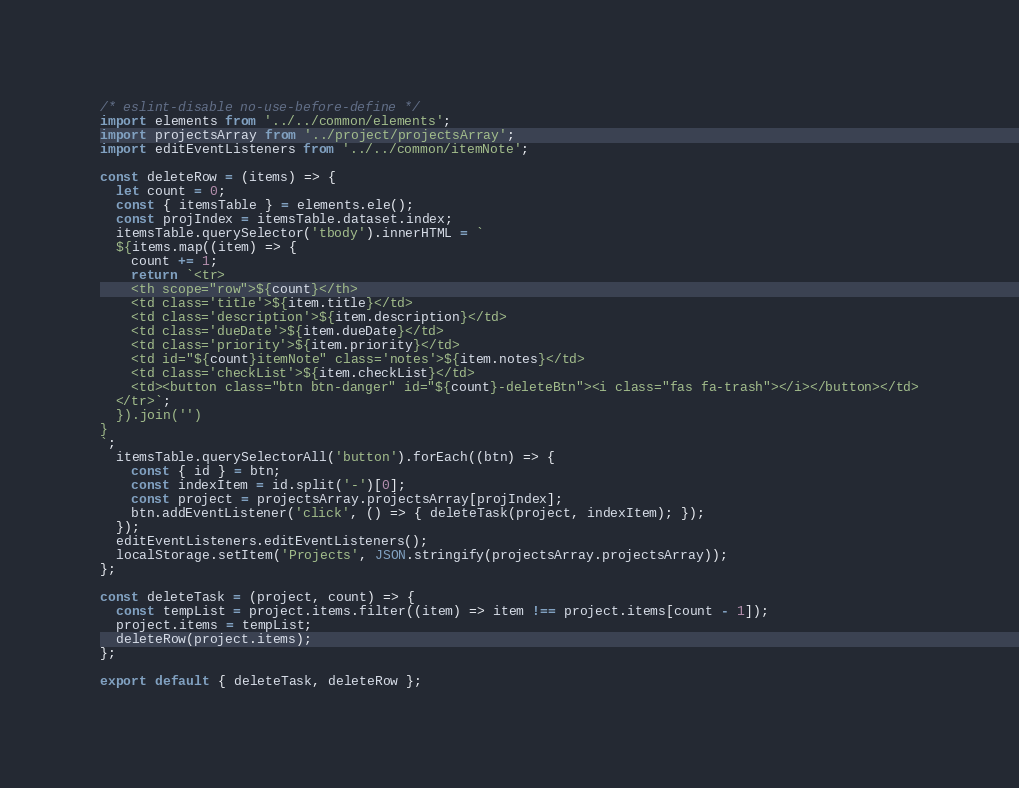Convert code to text. <code><loc_0><loc_0><loc_500><loc_500><_JavaScript_>/* eslint-disable no-use-before-define */
import elements from '../../common/elements';
import projectsArray from '../project/projectsArray';
import editEventListeners from '../../common/itemNote';

const deleteRow = (items) => {
  let count = 0;
  const { itemsTable } = elements.ele();
  const projIndex = itemsTable.dataset.index;
  itemsTable.querySelector('tbody').innerHTML = `
  ${items.map((item) => {
    count += 1;
    return `<tr>
    <th scope="row">${count}</th>
    <td class='title'>${item.title}</td>
    <td class='description'>${item.description}</td>
    <td class='dueDate'>${item.dueDate}</td>
    <td class='priority'>${item.priority}</td>
    <td id="${count}itemNote" class='notes'>${item.notes}</td>
    <td class='checkList'>${item.checkList}</td>
    <td><button class="btn btn-danger" id="${count}-deleteBtn"><i class="fas fa-trash"></i></button></td>
  </tr>`;
  }).join('')
}
`;
  itemsTable.querySelectorAll('button').forEach((btn) => {
    const { id } = btn;
    const indexItem = id.split('-')[0];
    const project = projectsArray.projectsArray[projIndex];
    btn.addEventListener('click', () => { deleteTask(project, indexItem); });
  });
  editEventListeners.editEventListeners();
  localStorage.setItem('Projects', JSON.stringify(projectsArray.projectsArray));
};

const deleteTask = (project, count) => {
  const tempList = project.items.filter((item) => item !== project.items[count - 1]);
  project.items = tempList;
  deleteRow(project.items);
};

export default { deleteTask, deleteRow };</code> 